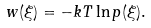<formula> <loc_0><loc_0><loc_500><loc_500>w ( \xi ) = - k T \ln p ( \xi ) .</formula> 